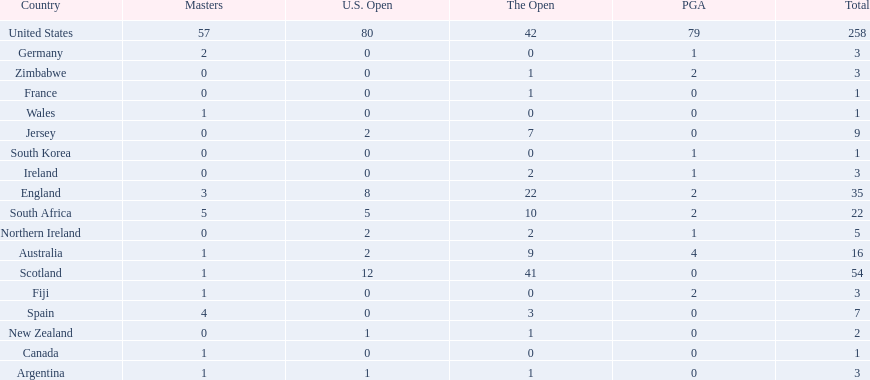What are all the countries? United States, Scotland, England, South Africa, Australia, Jersey, Spain, Northern Ireland, Argentina, Fiji, Germany, Ireland, Zimbabwe, New Zealand, Canada, France, South Korea, Wales. Which ones are located in africa? South Africa, Zimbabwe. Of those, which has the least champion golfers? Zimbabwe. 